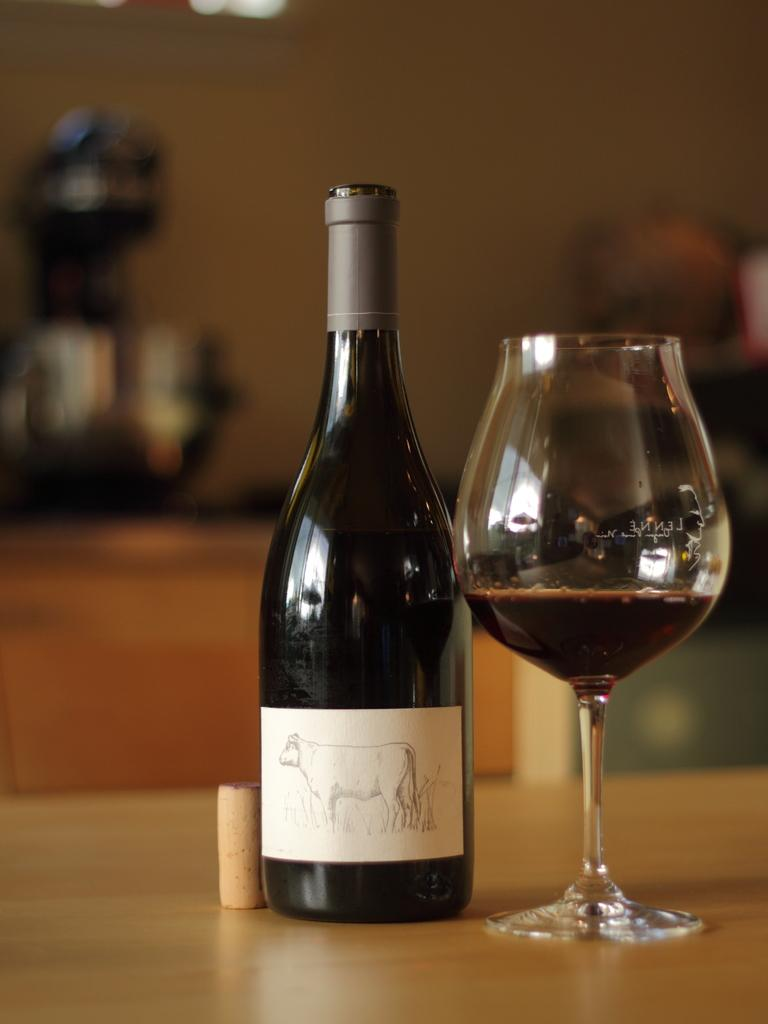What type of beverage container is in the image? There is a wine bottle in the image. What is the glass used for in the image? The glass is likely used for drinking the wine. What is the surface that the wine bottle and glass are placed on? The wine bottle and glass are on a wooden table. What type of truck is visible in the image? There is no truck present in the image. Does the existence of the wooden table in the image prove the existence of wood as a material? The presence of a wooden table in the image does suggest that wood exists as a material, but it does not prove its existence. 